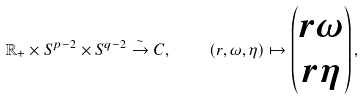Convert formula to latex. <formula><loc_0><loc_0><loc_500><loc_500>\mathbb { R } _ { + } \times S ^ { p - 2 } \times S ^ { q - 2 } \overset { \sim } { \to } C , \quad ( r , \omega , \eta ) \mapsto \begin{pmatrix} r \omega \\ r \eta \end{pmatrix} ,</formula> 